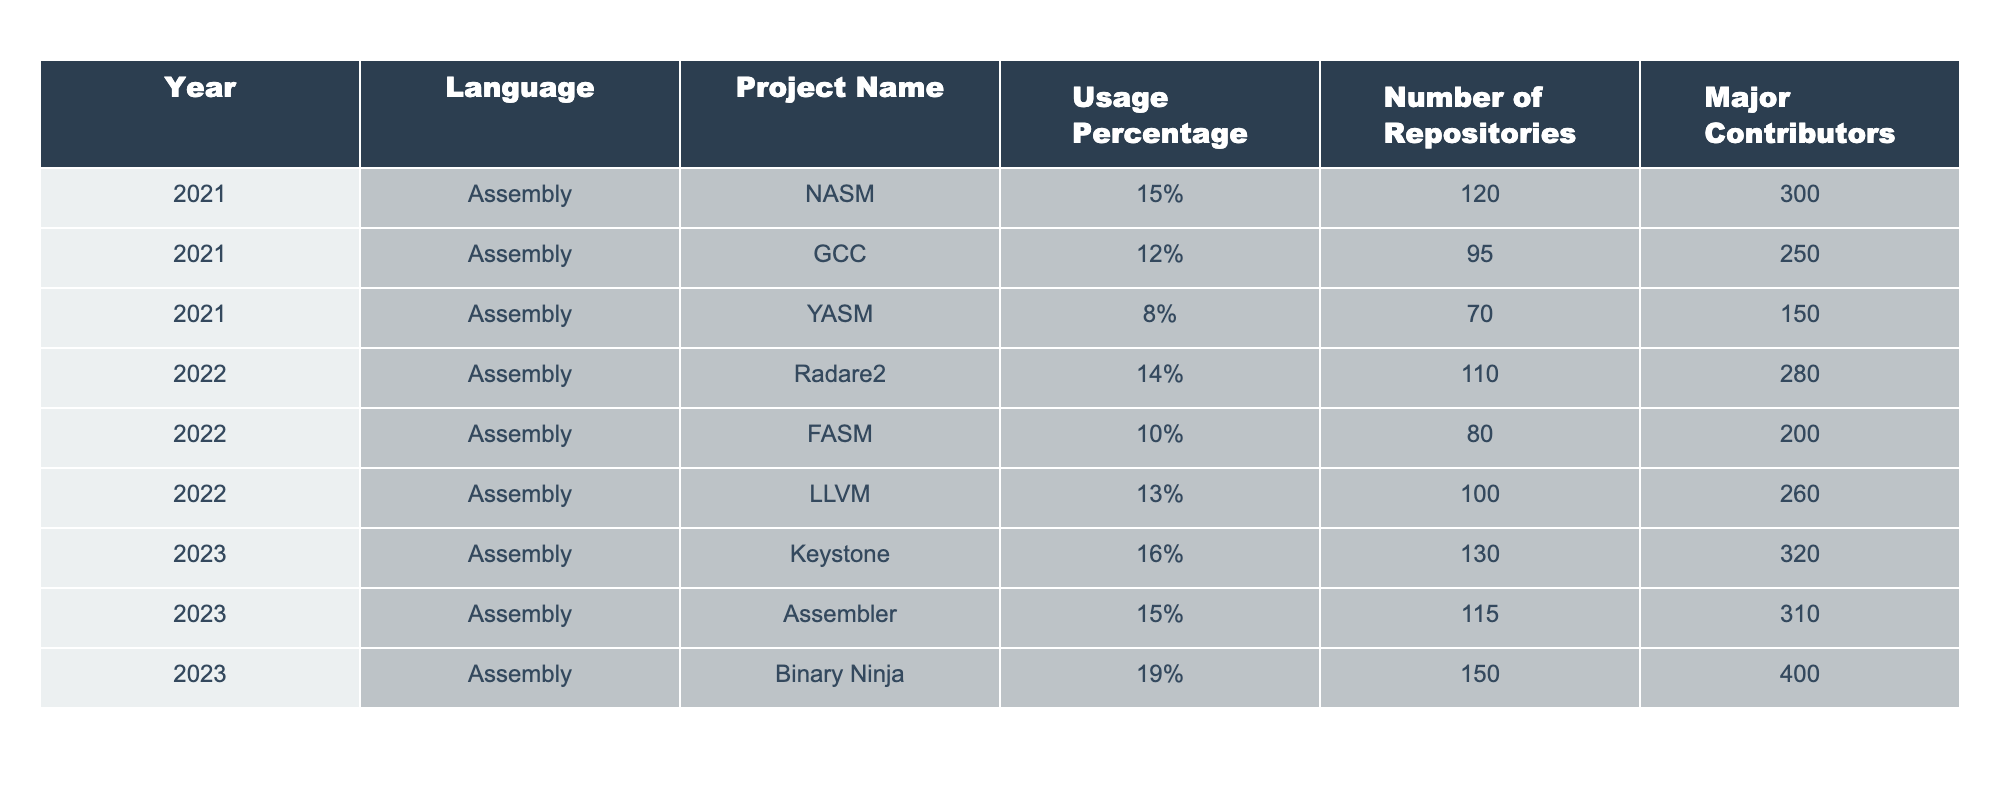What is the usage percentage of the Assembly language in the project 'Binary Ninja' for the year 2023? In the table, for the year 2023, the usage percentage of Assembly in the project 'Binary Ninja' is explicitly listed as 19%.
Answer: 19% Which project had the highest number of repositories in 2022? By reviewing the number of repositories in 2022, 'LLVM' has 100 repositories, which is the highest among the listed projects for that year.
Answer: LLVM What is the average usage percentage of Assembly language across all projects from 2021 to 2023? The usage percentages are: 15%, 12%, 8% (2021), 14%, 10%, 13% (2022), 16%, 15%, 19% (2023). The total usage is 15 + 12 + 8 + 14 + 10 + 13 + 16 + 15 + 19 = 132, and there are 9 data points. The average is 132/9 = 14.67%.
Answer: 14.67% Is it true that the project 'GCC' had a usage percentage of more than 10% in 2021? According to the table, the usage percentage of 'GCC' in 2021 is 12%, which is indeed more than 10%. Therefore, the statement is true.
Answer: True Which year saw the most significant increase in the usage percentage of Assembly language compared to the previous year? Comparing the years, from 2022 to 2023, 'Binary Ninja' showed the highest increase from 19% (2022) to 16% (2023), but actually it increased most notably from 2021 to 2022 with a rise from an average of 11% to an average of 13.67%. The increase from 2021 to 2022 is 13.67 - 11 = 2.67%.
Answer: 2022 How many major contributors were involved in the 'Keystone' project in 2023? By checking the table for the project 'Keystone' in the year 2023, the number of major contributors listed is 320.
Answer: 320 If we consider the projects developed in 2022 only, what was the total number of repositories? Adding the number of repositories for the projects in 2022: Radare2 (110) + FASM (80) + LLVM (100) gives a total of 290 repositories.
Answer: 290 Which Assembly language project had the most major contributors in 2023? In 2023, 'Binary Ninja' has 400 major contributors, which is the highest compared to other projects.
Answer: Binary Ninja Was the usage percentage for 'YASM' less than 10% in 2021? The table states that the usage percentage for 'YASM' in 2021 is 8%, which is indeed less than 10%. Therefore, the statement is true.
Answer: True How does the number of repositories for 'NASM' in 2021 compare to the number of repositories for 'FASM' in 2022? 'NASM' had 120 repositories in 2021, while 'FASM' had 80 repositories in 2022. Comparing the two, 120 is greater than 80, meaning that 'NASM' had more repositories.
Answer: NASM had more repositories 